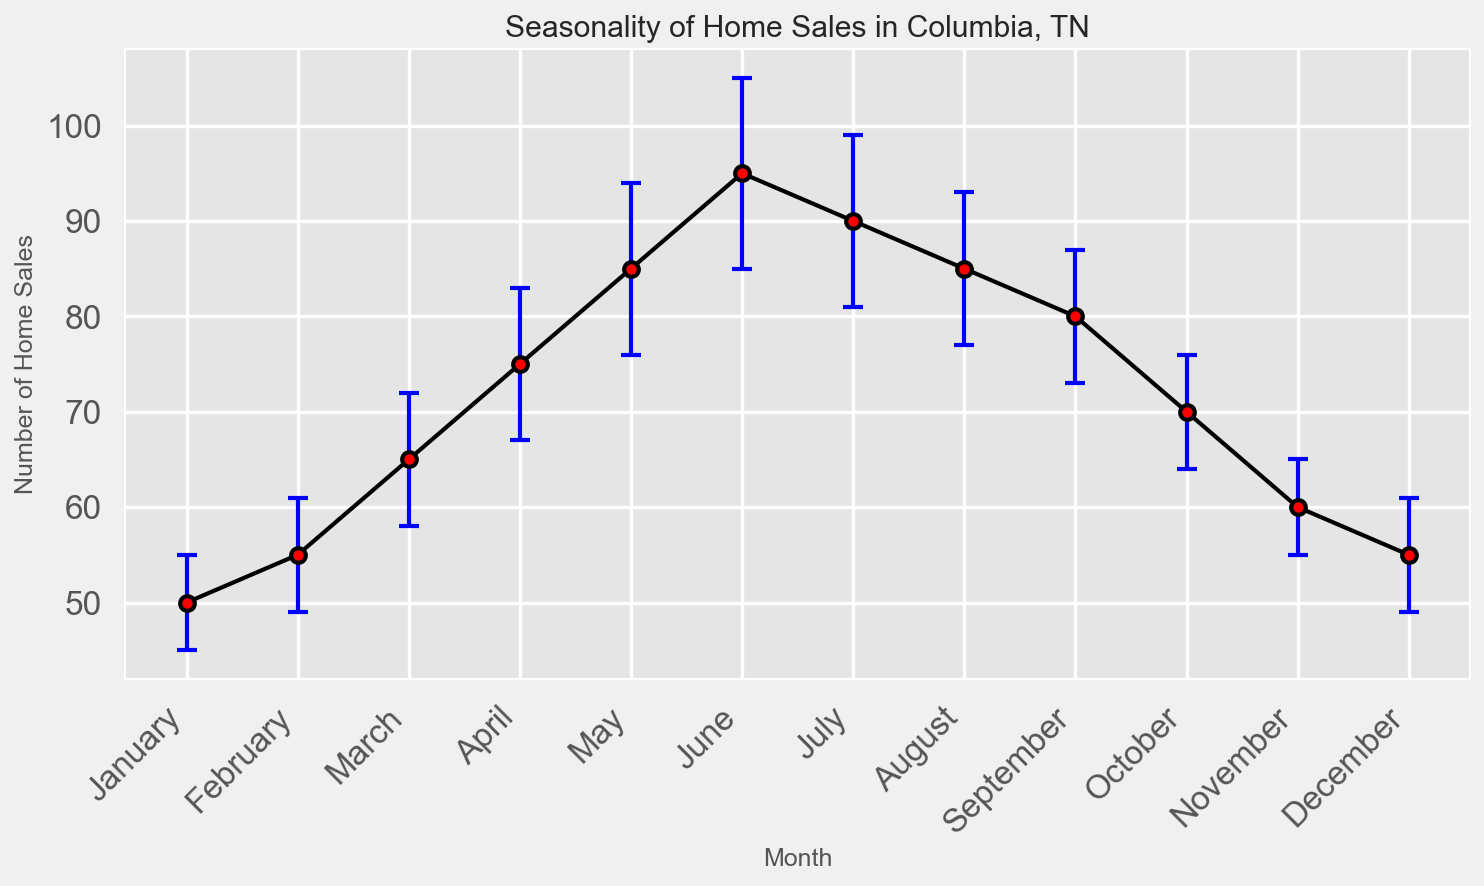What is the month with the highest average number of home sales? To find the highest value, look at the Monthly_Average data points on the vertical axis of the figure. The peak corresponds to June with an average of 95 home sales.
Answer: June During which months are the average home sales equal to 85? Check for months where the Monthly_Average on the vertical axis is at 85. The months corresponding to this value on the figure are May and August.
Answer: May, August What's the difference in average home sales between March and October? Locate the Monthly_Average points for March and October. March has 65 home sales and October has 70. Calculate the difference: 70 - 65 = 5.
Answer: 5 How does the standard deviation of home sales in January compare to that in March? January has a standard deviation of 5, and March has a standard deviation of 7. So, January’s standard deviation is less than March’s.
Answer: January < March Which month has the smallest error bar, indicating the lowest standard deviation? The height of the error bars visually represents the standard deviation. The shortest error bar belongs to January and November, both with a standard deviation of 5.
Answer: January, November What is the combined average home sales for February, March, and April? Sum up the Monthly_Average values for February (55), March (65), and April (75). The combined total is 55 + 65 + 75 = 195.
Answer: 195 In which months do the home sales averages fall between the range of 80 and 90? Identify months where the Monthly_Average values are between 80 and 90. These values correspond to May, June, July, August, and September.
Answer: May, June, July, August, September Which months have a higher average number of home sales than July? July has an average of 90 home sales. Check which months have Monthly_Average values higher than this. Only June with 95 falls into this category.
Answer: June How much higher are home sales on average in May than in January? May’s Monthly_Average is 85 and January's is 50. Subtract January’s value from May’s: 85 - 50 = 35.
Answer: 35 What is the visual indication on the plot that depicts variability in home sales across the months? The error bars extending above and below the average points represent the variability, with blue caps and black lines showing standard deviation.
Answer: Error bars 